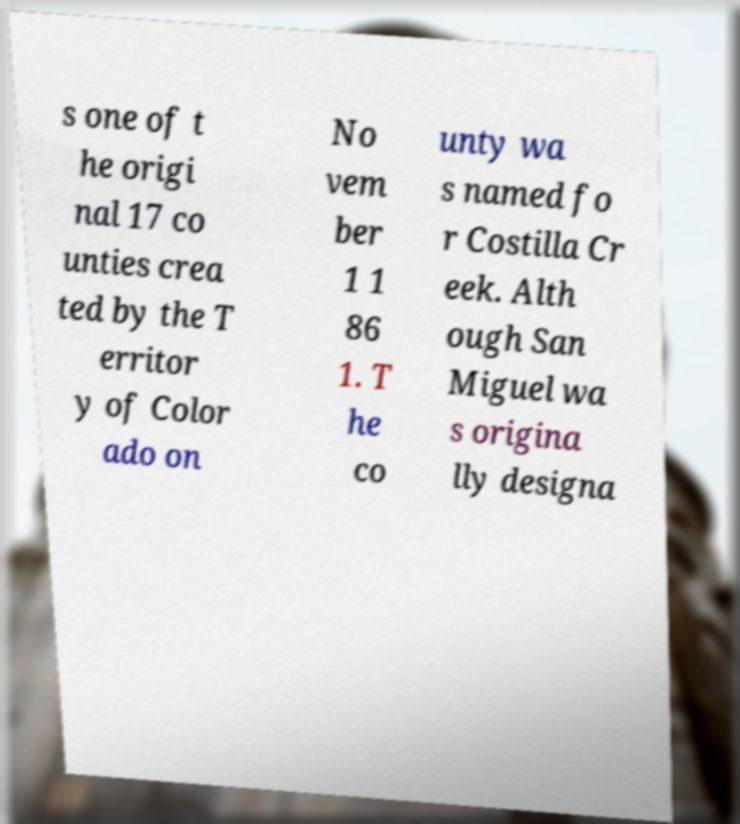Please identify and transcribe the text found in this image. s one of t he origi nal 17 co unties crea ted by the T erritor y of Color ado on No vem ber 1 1 86 1. T he co unty wa s named fo r Costilla Cr eek. Alth ough San Miguel wa s origina lly designa 